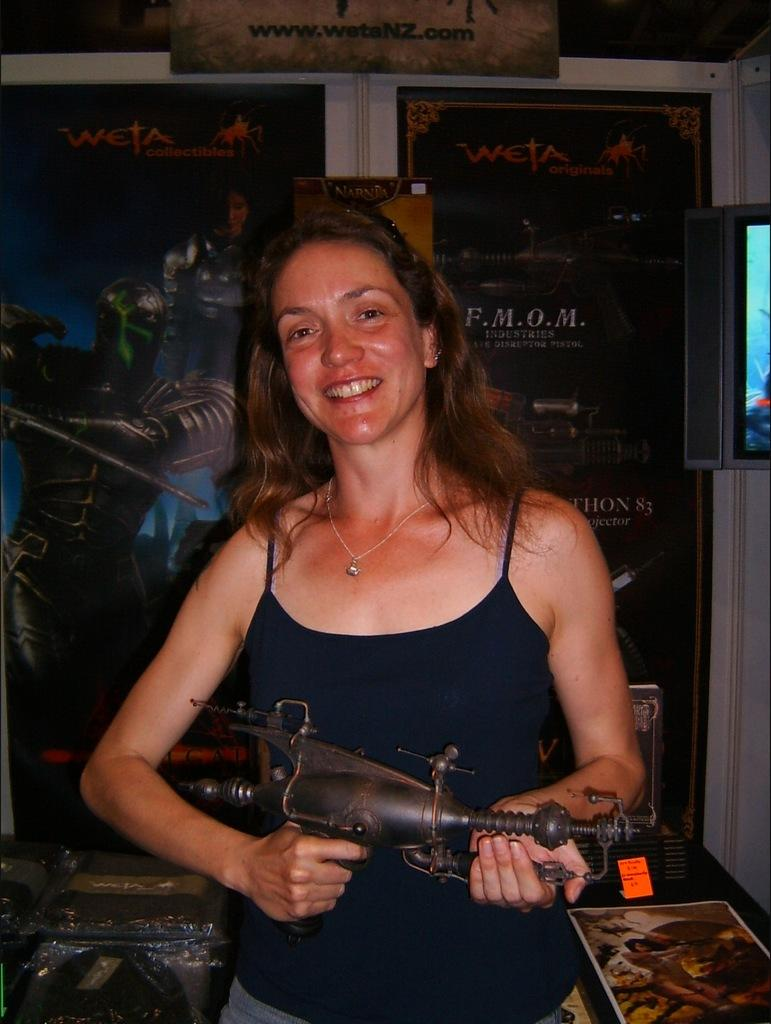Who is the main subject in the image? There is a woman in the image. What is the woman doing in the image? The woman is standing and smiling. What object is the woman holding in her hand? The woman is holding a gun in her hand. What can be seen in the background of the image? There is a poster visible in the background of the image. What effect does the woman's uncle have on her in the image? There is no mention of an uncle in the image, so it is impossible to determine any effect he might have. 